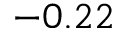<formula> <loc_0><loc_0><loc_500><loc_500>- 0 . 2 2</formula> 